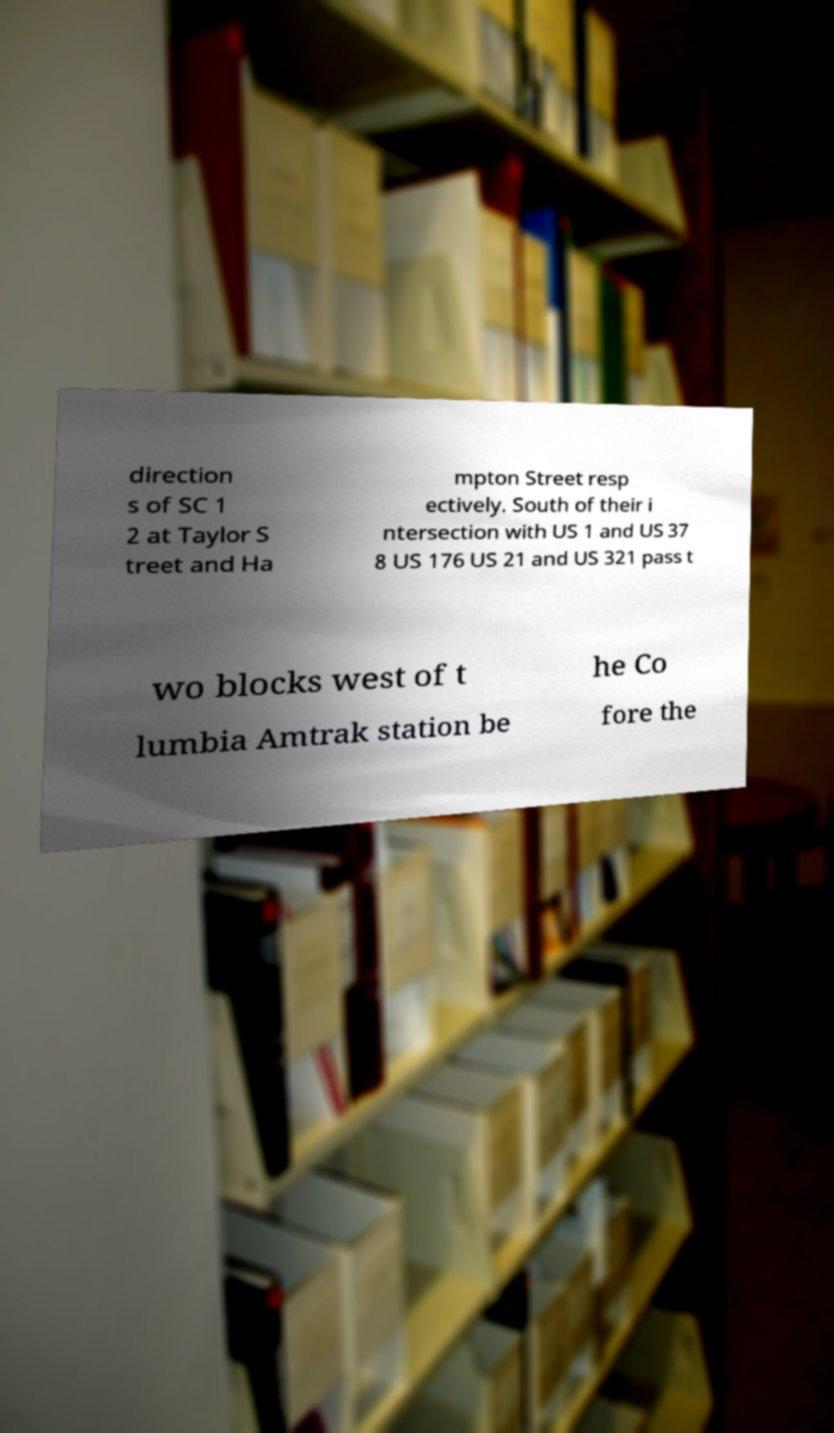Can you read and provide the text displayed in the image?This photo seems to have some interesting text. Can you extract and type it out for me? direction s of SC 1 2 at Taylor S treet and Ha mpton Street resp ectively. South of their i ntersection with US 1 and US 37 8 US 176 US 21 and US 321 pass t wo blocks west of t he Co lumbia Amtrak station be fore the 